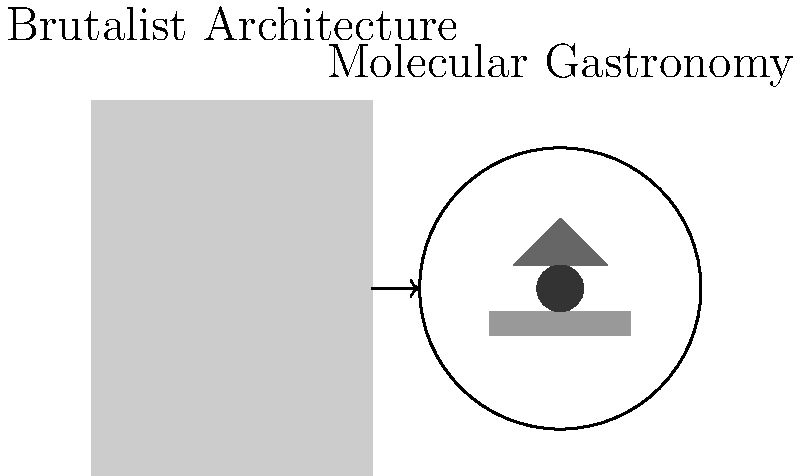Analyze the parallels between Brutalist architecture and modern molecular gastronomy plating techniques as depicted in the image. How do the principles of Brutalism manifest in the geometric arrangement of food elements, and what does this reveal about the intersection of architectural and culinary aesthetics in contemporary French culture? To answer this question, we need to analyze the image and draw connections between Brutalist architecture and molecular gastronomy plating techniques:

1. Geometric forms: Brutalist architecture is characterized by its use of simple, block-like forms. In the image, we see a stark, rectangular building representing Brutalism. Similarly, the food plating uses geometric shapes (rectangle, triangle, circle) for the food elements.

2. Emphasis on raw materials: Brutalism often exposes raw concrete and structural elements. In molecular gastronomy, chefs often deconstruct dishes to their basic elements, presenting them in pure forms. The distinct, separate food elements on the plate mirror this approach.

3. Minimalism: Both Brutalist architecture and the plating technique shown eschew unnecessary ornamentation, focusing on essential forms and structures.

4. Contrast: Brutalist buildings often feature strong contrasts in texture and form. The plating technique uses contrasting shapes and shades to create visual interest, mimicking this architectural principle.

5. Functionality: Brutalism prioritizes function over form. In molecular gastronomy, each element on the plate often serves a specific flavor or textural purpose, reflecting this functional approach.

6. Cultural commentary: Both Brutalism and molecular gastronomy can be seen as reactions against traditional forms in their respective fields. The juxtaposition in the image suggests a parallel evolution in French architectural and culinary aesthetics.

7. Spatial arrangement: The careful placement of food elements echoes the intentional use of space and form in Brutalist architecture.

This parallel reveals a broader cultural shift in French aesthetics, embracing modernist principles across different creative disciplines. It suggests a cross-pollination of ideas between architecture and cuisine, both moving towards more abstract, deconstructed forms that challenge traditional notions of beauty and functionality.
Answer: Shared principles of geometry, minimalism, and deconstruction in Brutalism and molecular gastronomy reflect a modernist aesthetic shift in French culture. 